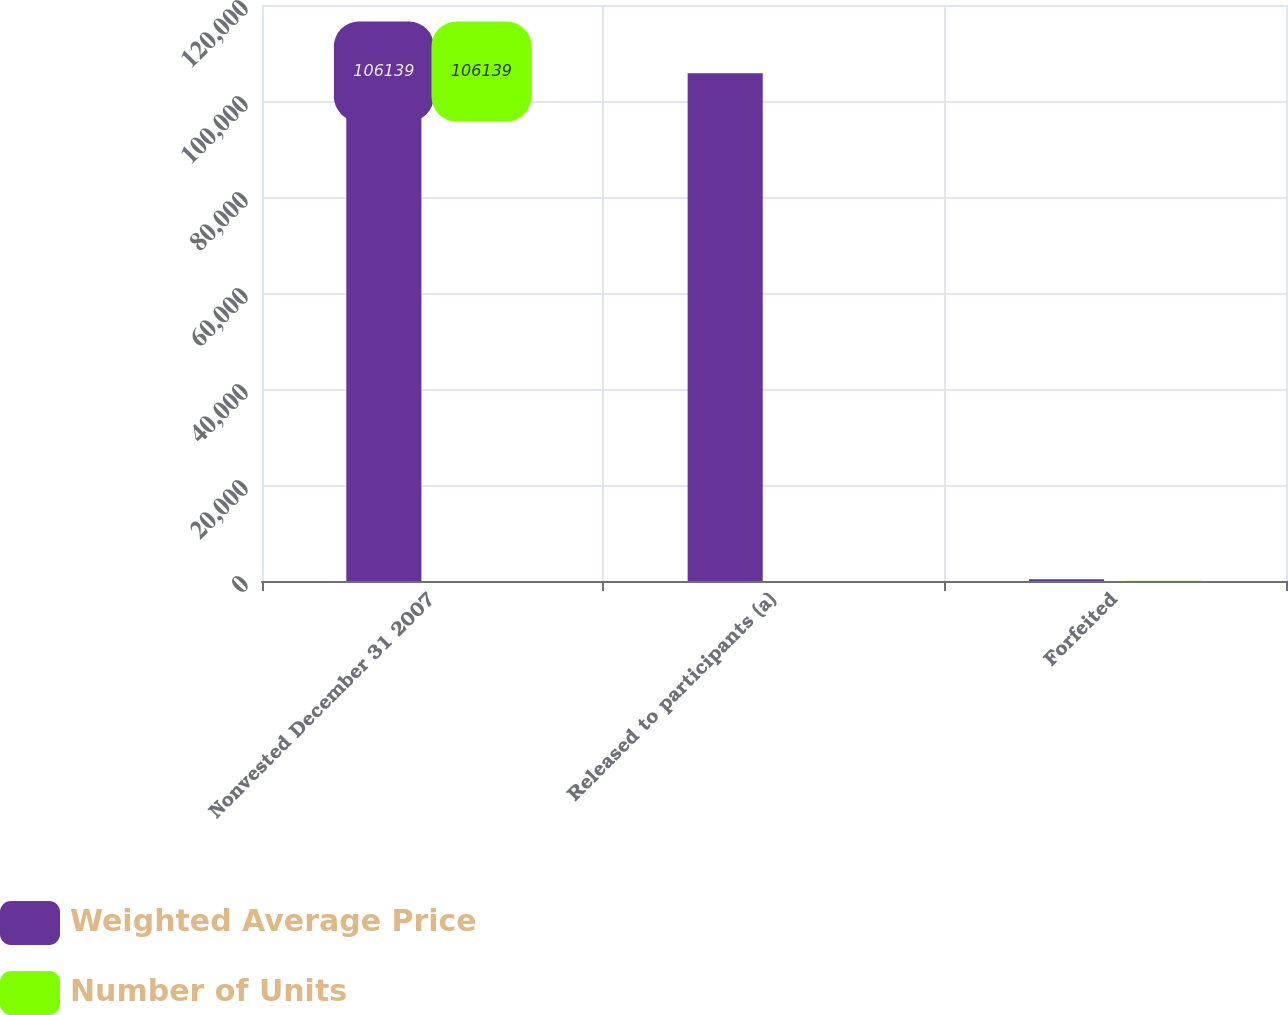Convert chart. <chart><loc_0><loc_0><loc_500><loc_500><stacked_bar_chart><ecel><fcel>Nonvested December 31 2007<fcel>Released to participants (a)<fcel>Forfeited<nl><fcel>Weighted Average Price<fcel>106139<fcel>105758<fcel>381<nl><fcel>Number of Units<fcel>25.48<fcel>25.48<fcel>26.57<nl></chart> 